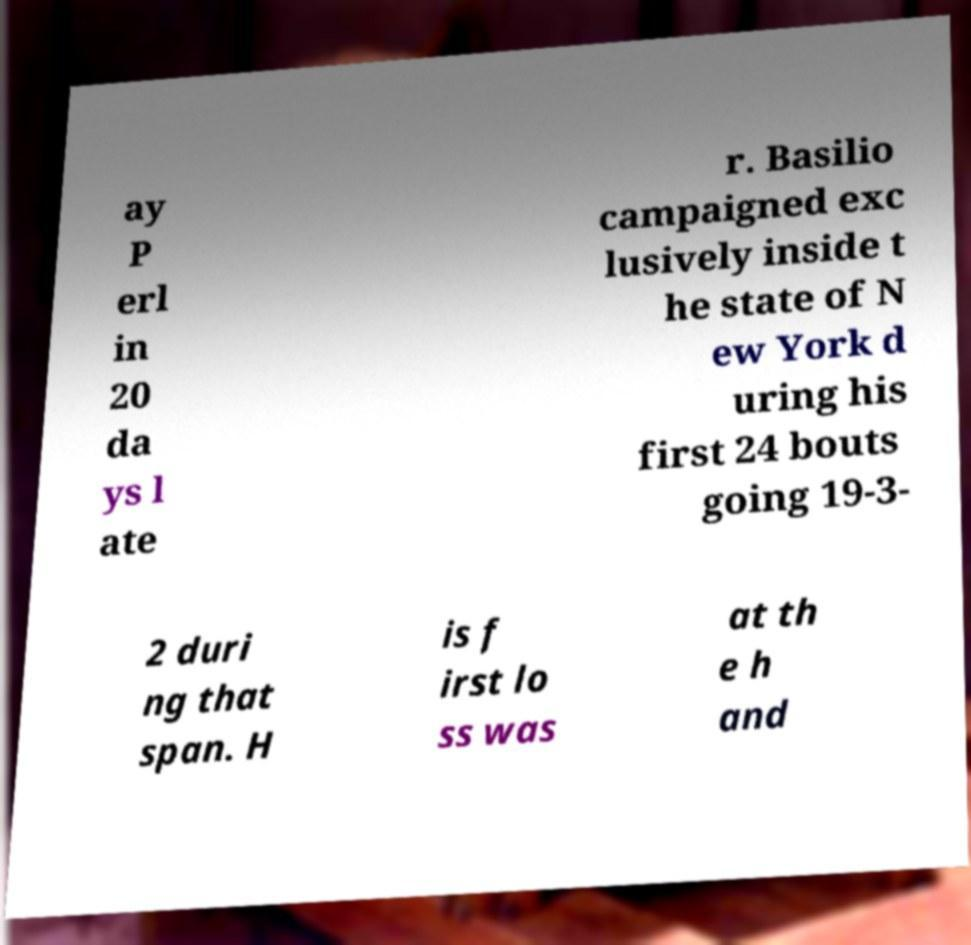Can you accurately transcribe the text from the provided image for me? ay P erl in 20 da ys l ate r. Basilio campaigned exc lusively inside t he state of N ew York d uring his first 24 bouts going 19-3- 2 duri ng that span. H is f irst lo ss was at th e h and 